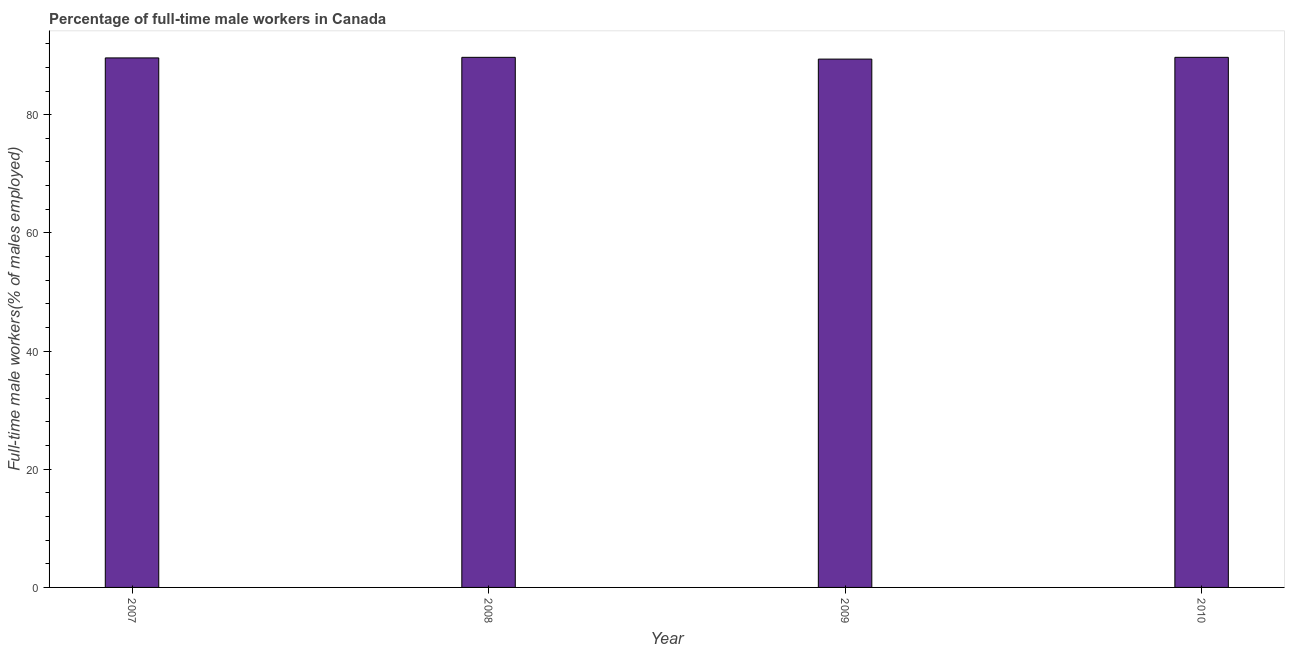Does the graph contain any zero values?
Your response must be concise. No. Does the graph contain grids?
Keep it short and to the point. No. What is the title of the graph?
Offer a terse response. Percentage of full-time male workers in Canada. What is the label or title of the Y-axis?
Ensure brevity in your answer.  Full-time male workers(% of males employed). What is the percentage of full-time male workers in 2008?
Your response must be concise. 89.7. Across all years, what is the maximum percentage of full-time male workers?
Ensure brevity in your answer.  89.7. Across all years, what is the minimum percentage of full-time male workers?
Your response must be concise. 89.4. What is the sum of the percentage of full-time male workers?
Offer a very short reply. 358.4. What is the difference between the percentage of full-time male workers in 2008 and 2010?
Provide a short and direct response. 0. What is the average percentage of full-time male workers per year?
Make the answer very short. 89.6. What is the median percentage of full-time male workers?
Your response must be concise. 89.65. In how many years, is the percentage of full-time male workers greater than 32 %?
Provide a short and direct response. 4. Do a majority of the years between 2008 and 2010 (inclusive) have percentage of full-time male workers greater than 36 %?
Your response must be concise. Yes. What is the ratio of the percentage of full-time male workers in 2007 to that in 2009?
Offer a terse response. 1. Is the percentage of full-time male workers in 2009 less than that in 2010?
Your answer should be compact. Yes. Is the difference between the percentage of full-time male workers in 2007 and 2010 greater than the difference between any two years?
Your response must be concise. No. How many years are there in the graph?
Your response must be concise. 4. What is the difference between two consecutive major ticks on the Y-axis?
Your response must be concise. 20. Are the values on the major ticks of Y-axis written in scientific E-notation?
Make the answer very short. No. What is the Full-time male workers(% of males employed) of 2007?
Offer a terse response. 89.6. What is the Full-time male workers(% of males employed) in 2008?
Keep it short and to the point. 89.7. What is the Full-time male workers(% of males employed) in 2009?
Offer a very short reply. 89.4. What is the Full-time male workers(% of males employed) of 2010?
Your response must be concise. 89.7. What is the difference between the Full-time male workers(% of males employed) in 2007 and 2009?
Your answer should be compact. 0.2. What is the difference between the Full-time male workers(% of males employed) in 2007 and 2010?
Make the answer very short. -0.1. What is the difference between the Full-time male workers(% of males employed) in 2008 and 2009?
Make the answer very short. 0.3. What is the difference between the Full-time male workers(% of males employed) in 2009 and 2010?
Your answer should be compact. -0.3. What is the ratio of the Full-time male workers(% of males employed) in 2007 to that in 2008?
Your response must be concise. 1. What is the ratio of the Full-time male workers(% of males employed) in 2007 to that in 2010?
Offer a terse response. 1. What is the ratio of the Full-time male workers(% of males employed) in 2008 to that in 2010?
Make the answer very short. 1. 